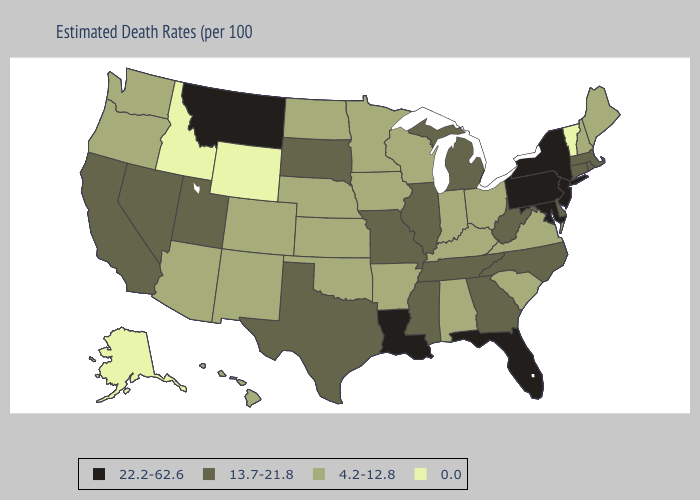What is the lowest value in states that border West Virginia?
Answer briefly. 4.2-12.8. Does New York have the highest value in the USA?
Write a very short answer. Yes. What is the highest value in the USA?
Be succinct. 22.2-62.6. What is the lowest value in states that border Iowa?
Keep it brief. 4.2-12.8. Does Connecticut have the same value as Mississippi?
Quick response, please. Yes. What is the value of Idaho?
Be succinct. 0.0. Name the states that have a value in the range 4.2-12.8?
Give a very brief answer. Alabama, Arizona, Arkansas, Colorado, Hawaii, Indiana, Iowa, Kansas, Kentucky, Maine, Minnesota, Nebraska, New Hampshire, New Mexico, North Dakota, Ohio, Oklahoma, Oregon, South Carolina, Virginia, Washington, Wisconsin. Does Virginia have the same value as Michigan?
Short answer required. No. What is the value of Iowa?
Quick response, please. 4.2-12.8. Name the states that have a value in the range 22.2-62.6?
Write a very short answer. Florida, Louisiana, Maryland, Montana, New Jersey, New York, Pennsylvania. Which states have the lowest value in the Northeast?
Short answer required. Vermont. What is the lowest value in the USA?
Answer briefly. 0.0. Which states hav the highest value in the Northeast?
Write a very short answer. New Jersey, New York, Pennsylvania. Is the legend a continuous bar?
Be succinct. No. What is the value of Missouri?
Keep it brief. 13.7-21.8. 